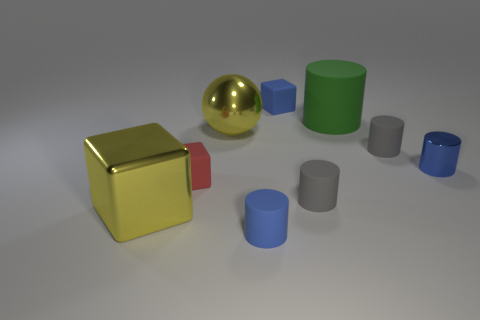Do the metal thing in front of the metal cylinder and the big green rubber object have the same shape?
Offer a terse response. No. Are there fewer large matte objects that are on the right side of the green object than cubes on the left side of the blue metal cylinder?
Offer a terse response. Yes. What is the large yellow ball made of?
Provide a succinct answer. Metal. There is a shiny sphere; does it have the same color as the large block in front of the tiny blue cube?
Offer a very short reply. Yes. What number of blue things are behind the large green rubber cylinder?
Provide a short and direct response. 1. Is the number of red matte blocks that are in front of the blue matte cylinder less than the number of blue blocks?
Make the answer very short. Yes. What color is the tiny metallic cylinder?
Provide a succinct answer. Blue. There is a cylinder that is in front of the big yellow cube; does it have the same color as the metallic cylinder?
Your answer should be compact. Yes. What color is the other small object that is the same shape as the small red matte object?
Offer a terse response. Blue. What number of large things are blue spheres or metal spheres?
Offer a terse response. 1. 